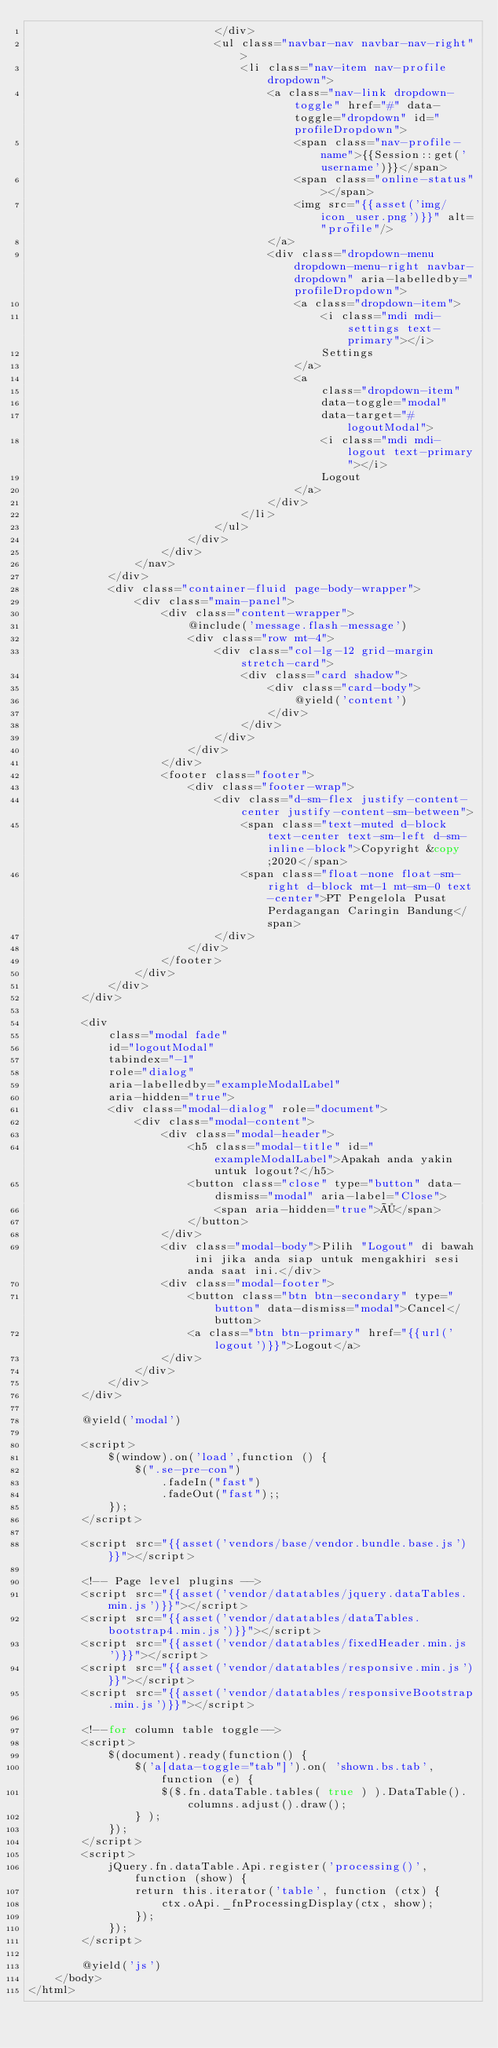<code> <loc_0><loc_0><loc_500><loc_500><_PHP_>							</div>
							<ul class="navbar-nav navbar-nav-right">
								<li class="nav-item nav-profile dropdown">
									<a class="nav-link dropdown-toggle" href="#" data-toggle="dropdown" id="profileDropdown">
										<span class="nav-profile-name">{{Session::get('username')}}</span>
										<span class="online-status"></span>
										<img src="{{asset('img/icon_user.png')}}" alt="profile"/>
									</a>
									<div class="dropdown-menu dropdown-menu-right navbar-dropdown" aria-labelledby="profileDropdown">
										<a class="dropdown-item">
											<i class="mdi mdi-settings text-primary"></i>
											Settings
										</a>
                                        <a 
                                            class="dropdown-item"
                                            data-toggle="modal"
                                            data-target="#logoutModal">
											<i class="mdi mdi-logout text-primary"></i>
											Logout
										</a>
									</div>
								</li>
							</ul>
						</div>
					</div>
				</nav>
			</div>
			<div class="container-fluid page-body-wrapper">
				<div class="main-panel">
					<div class="content-wrapper">
                        @include('message.flash-message') 
						<div class="row mt-4">
							<div class="col-lg-12 grid-margin stretch-card">
								<div class="card shadow">
									<div class="card-body">
										@yield('content')
									</div>
								</div>
							</div>
						</div>
					</div>
					<footer class="footer">
						<div class="footer-wrap">
							<div class="d-sm-flex justify-content-center justify-content-sm-between">
								<span class="text-muted d-block text-center text-sm-left d-sm-inline-block">Copyright &copy;2020</span>
								<span class="float-none float-sm-right d-block mt-1 mt-sm-0 text-center">PT Pengelola Pusat Perdagangan Caringin Bandung</span>
							</div>
						</div>
					</footer>
				</div>
			</div>
        </div>
        
        <div
            class="modal fade"
            id="logoutModal"
            tabindex="-1"
            role="dialog"
            aria-labelledby="exampleModalLabel"
            aria-hidden="true">
            <div class="modal-dialog" role="document">
                <div class="modal-content">
                    <div class="modal-header">
                        <h5 class="modal-title" id="exampleModalLabel">Apakah anda yakin untuk logout?</h5>
                        <button class="close" type="button" data-dismiss="modal" aria-label="Close">
                            <span aria-hidden="true">×</span>
                        </button>
                    </div>
                    <div class="modal-body">Pilih "Logout" di bawah ini jika anda siap untuk mengakhiri sesi anda saat ini.</div>
                    <div class="modal-footer">
                        <button class="btn btn-secondary" type="button" data-dismiss="modal">Cancel</button>
                        <a class="btn btn-primary" href="{{url('logout')}}">Logout</a>
                    </div>
                </div>
            </div>
        </div>

        @yield('modal')

        <script>
            $(window).on('load',function () {
                $(".se-pre-con")
                    .fadeIn("fast")
                    .fadeOut("fast");;
            });
        </script>

        <script src="{{asset('vendors/base/vendor.bundle.base.js')}}"></script>

        <!-- Page level plugins -->
        <script src="{{asset('vendor/datatables/jquery.dataTables.min.js')}}"></script>
        <script src="{{asset('vendor/datatables/dataTables.bootstrap4.min.js')}}"></script>
        <script src="{{asset('vendor/datatables/fixedHeader.min.js')}}"></script>
        <script src="{{asset('vendor/datatables/responsive.min.js')}}"></script>
        <script src="{{asset('vendor/datatables/responsiveBootstrap.min.js')}}"></script>

        <!--for column table toggle-->
        <script>
            $(document).ready(function() {
                $('a[data-toggle="tab"]').on( 'shown.bs.tab', function (e) {
                    $($.fn.dataTable.tables( true ) ).DataTable().columns.adjust().draw();
                } ); 
            });
        </script>
        <script>
            jQuery.fn.dataTable.Api.register('processing()', function (show) {
                return this.iterator('table', function (ctx) {
                    ctx.oApi._fnProcessingDisplay(ctx, show);
                });
            });
        </script>
        
        @yield('js')
	</body>
</html></code> 